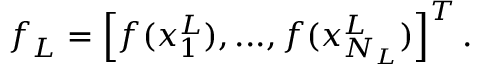Convert formula to latex. <formula><loc_0><loc_0><loc_500><loc_500>f _ { L } = \left [ f ( x _ { 1 } ^ { L } ) , \dots , f ( x _ { N _ { L } } ^ { L } ) \right ] ^ { T } .</formula> 